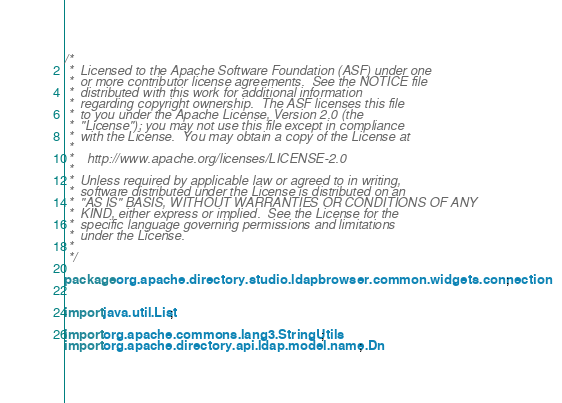<code> <loc_0><loc_0><loc_500><loc_500><_Java_>/*
 *  Licensed to the Apache Software Foundation (ASF) under one
 *  or more contributor license agreements.  See the NOTICE file
 *  distributed with this work for additional information
 *  regarding copyright ownership.  The ASF licenses this file
 *  to you under the Apache License, Version 2.0 (the
 *  "License"); you may not use this file except in compliance
 *  with the License.  You may obtain a copy of the License at
 *  
 *    http://www.apache.org/licenses/LICENSE-2.0
 *  
 *  Unless required by applicable law or agreed to in writing,
 *  software distributed under the License is distributed on an
 *  "AS IS" BASIS, WITHOUT WARRANTIES OR CONDITIONS OF ANY
 *  KIND, either express or implied.  See the License for the
 *  specific language governing permissions and limitations
 *  under the License. 
 *  
 */

package org.apache.directory.studio.ldapbrowser.common.widgets.connection;


import java.util.List;

import org.apache.commons.lang3.StringUtils;
import org.apache.directory.api.ldap.model.name.Dn;</code> 